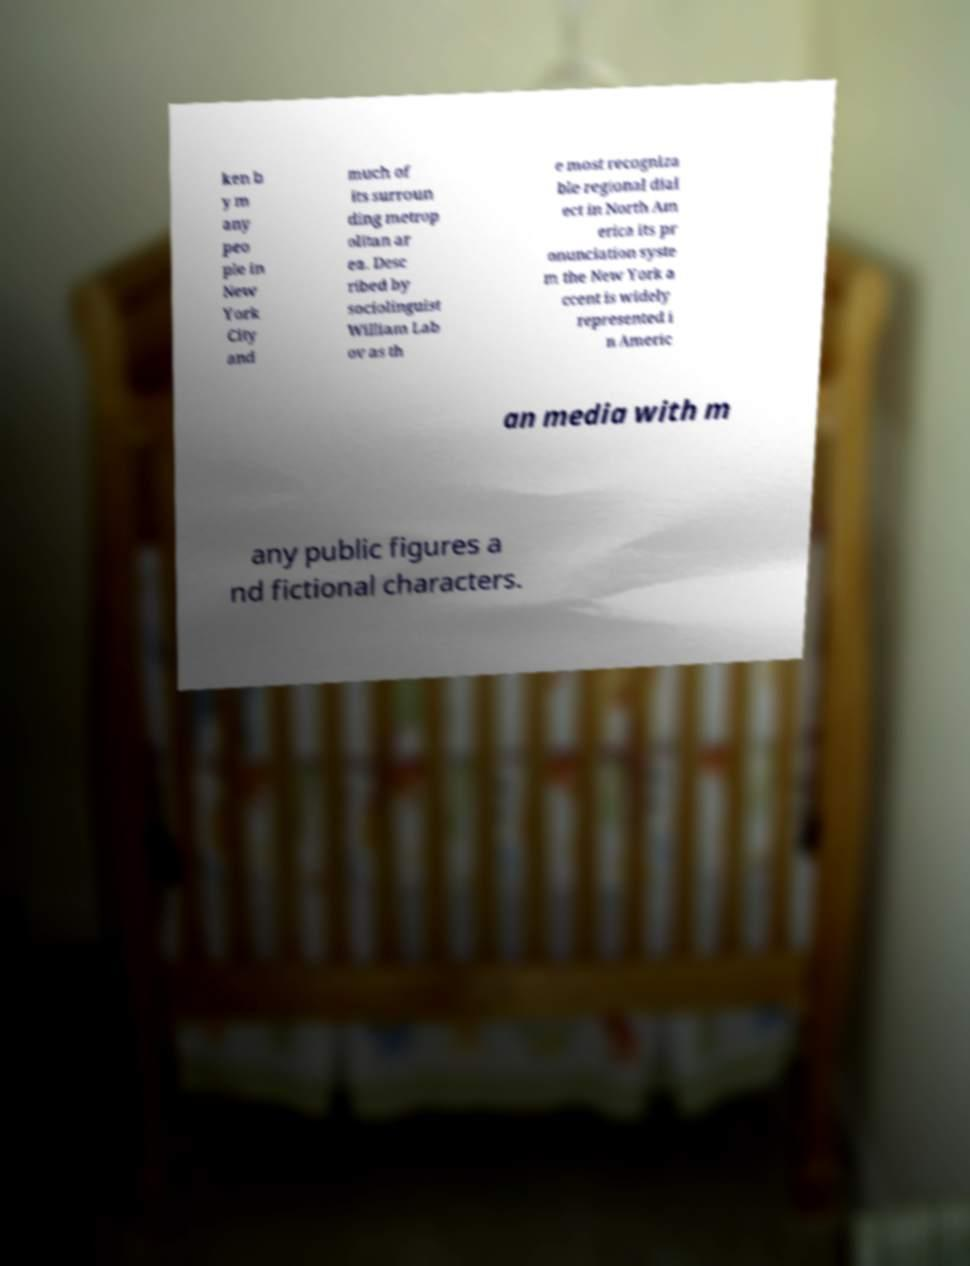Can you read and provide the text displayed in the image?This photo seems to have some interesting text. Can you extract and type it out for me? ken b y m any peo ple in New York City and much of its surroun ding metrop olitan ar ea. Desc ribed by sociolinguist William Lab ov as th e most recogniza ble regional dial ect in North Am erica its pr onunciation syste m the New York a ccent is widely represented i n Americ an media with m any public figures a nd fictional characters. 